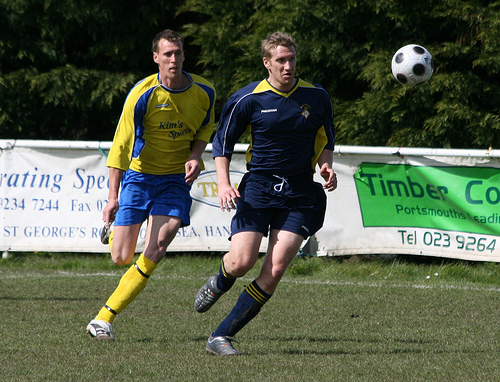<image>
Can you confirm if the man is to the right of the man? Yes. From this viewpoint, the man is positioned to the right side relative to the man. 